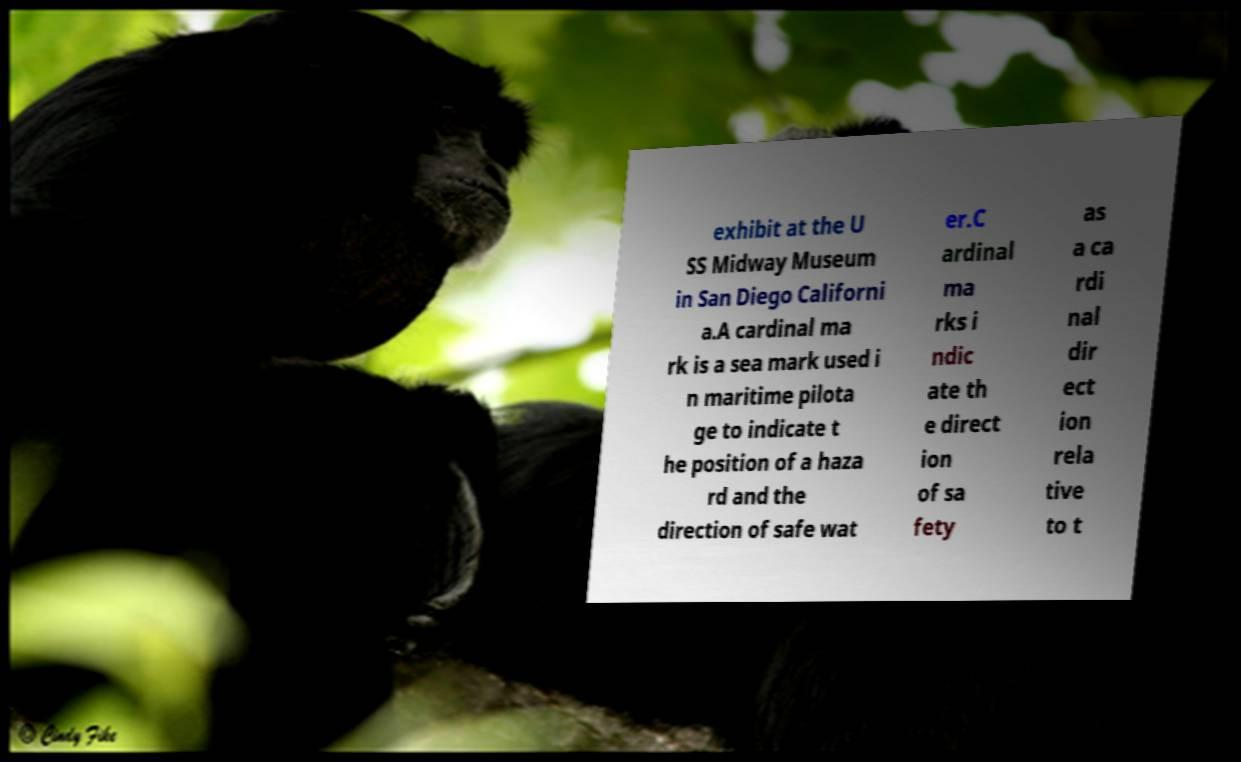Could you assist in decoding the text presented in this image and type it out clearly? exhibit at the U SS Midway Museum in San Diego Californi a.A cardinal ma rk is a sea mark used i n maritime pilota ge to indicate t he position of a haza rd and the direction of safe wat er.C ardinal ma rks i ndic ate th e direct ion of sa fety as a ca rdi nal dir ect ion rela tive to t 